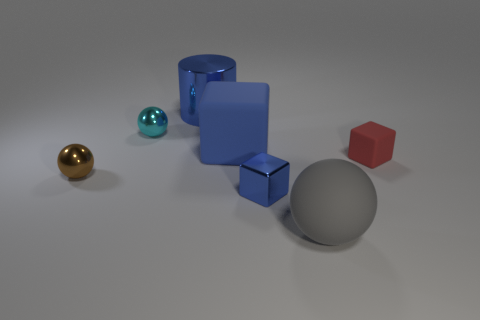Subtract all big spheres. How many spheres are left? 2 Subtract all blue blocks. How many blocks are left? 1 Subtract 1 cylinders. How many cylinders are left? 0 Add 3 small cyan cylinders. How many objects exist? 10 Subtract all spheres. How many objects are left? 4 Subtract all green spheres. How many brown cylinders are left? 0 Subtract all tiny rubber cubes. Subtract all big brown cylinders. How many objects are left? 6 Add 7 large rubber cubes. How many large rubber cubes are left? 8 Add 2 red shiny cylinders. How many red shiny cylinders exist? 2 Subtract 1 cyan balls. How many objects are left? 6 